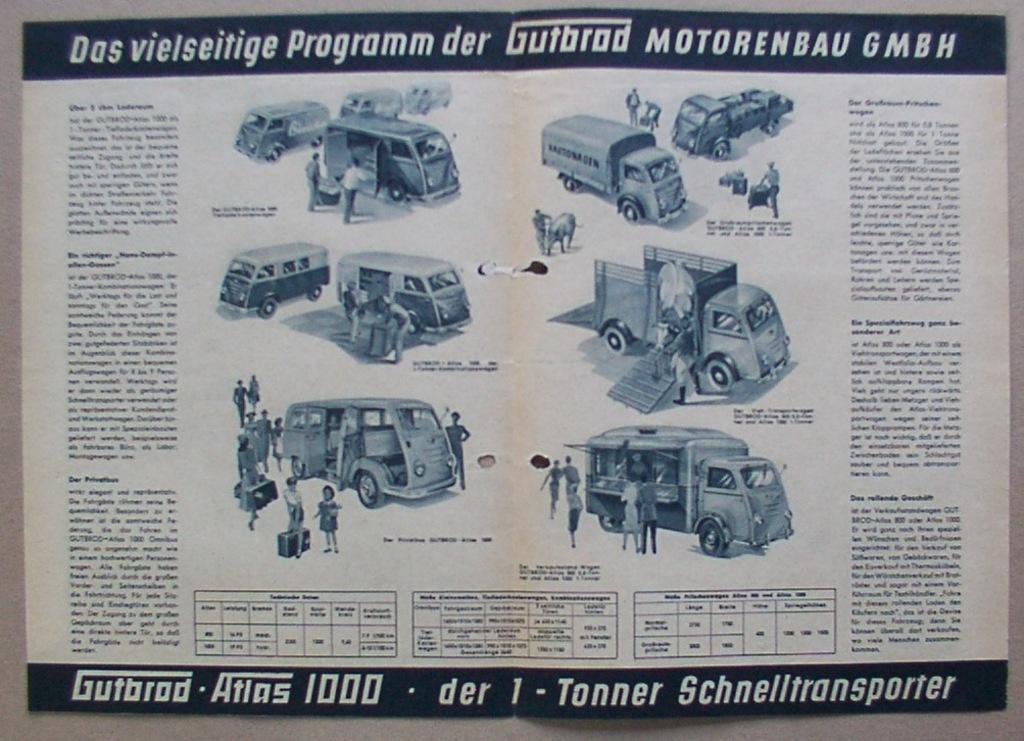Describe this image in one or two sentences. In the image we can see there is a poster and there are vehicles standing and people standing near the vehicles. There is matter written on the poster and the image is in black and white colour. 